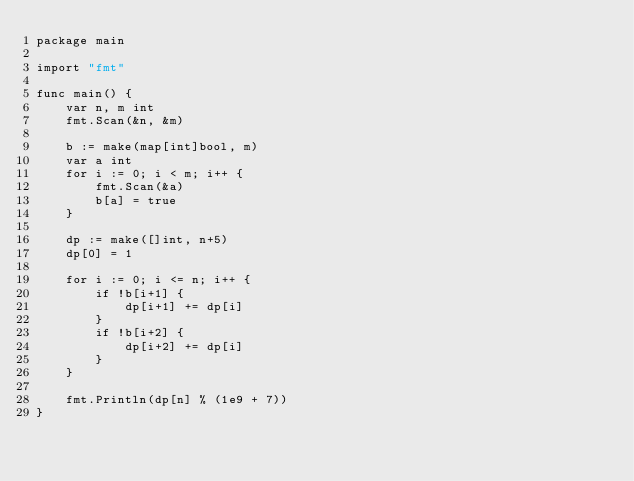<code> <loc_0><loc_0><loc_500><loc_500><_Go_>package main

import "fmt"

func main() {
	var n, m int
	fmt.Scan(&n, &m)

	b := make(map[int]bool, m)
	var a int
	for i := 0; i < m; i++ {
		fmt.Scan(&a)
		b[a] = true
	}

	dp := make([]int, n+5)
	dp[0] = 1

	for i := 0; i <= n; i++ {
		if !b[i+1] {
			dp[i+1] += dp[i]
		}
		if !b[i+2] {
			dp[i+2] += dp[i]
		}
	}

	fmt.Println(dp[n] % (1e9 + 7))
}
</code> 